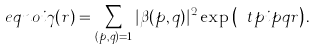<formula> <loc_0><loc_0><loc_500><loc_500>\ e q n o i \gamma ( r ) = \sum _ { ( p , q ) = 1 } | \beta ( p , q ) | ^ { 2 } \exp \left ( \ t p i p q r \right ) .</formula> 